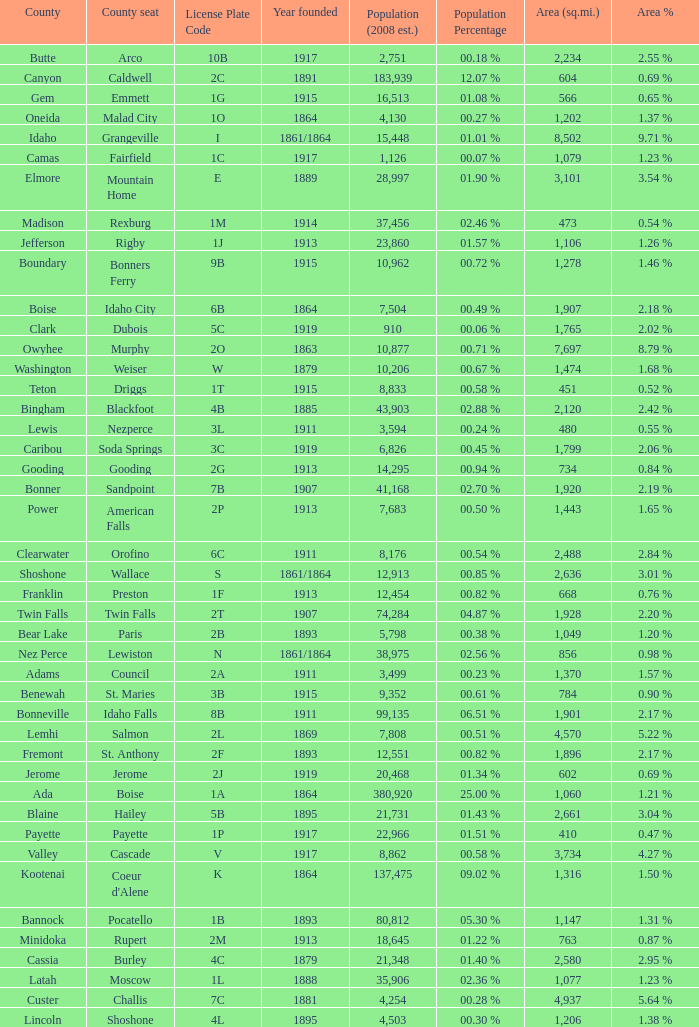What is the country seat for the license plate code 5c? Dubois. 